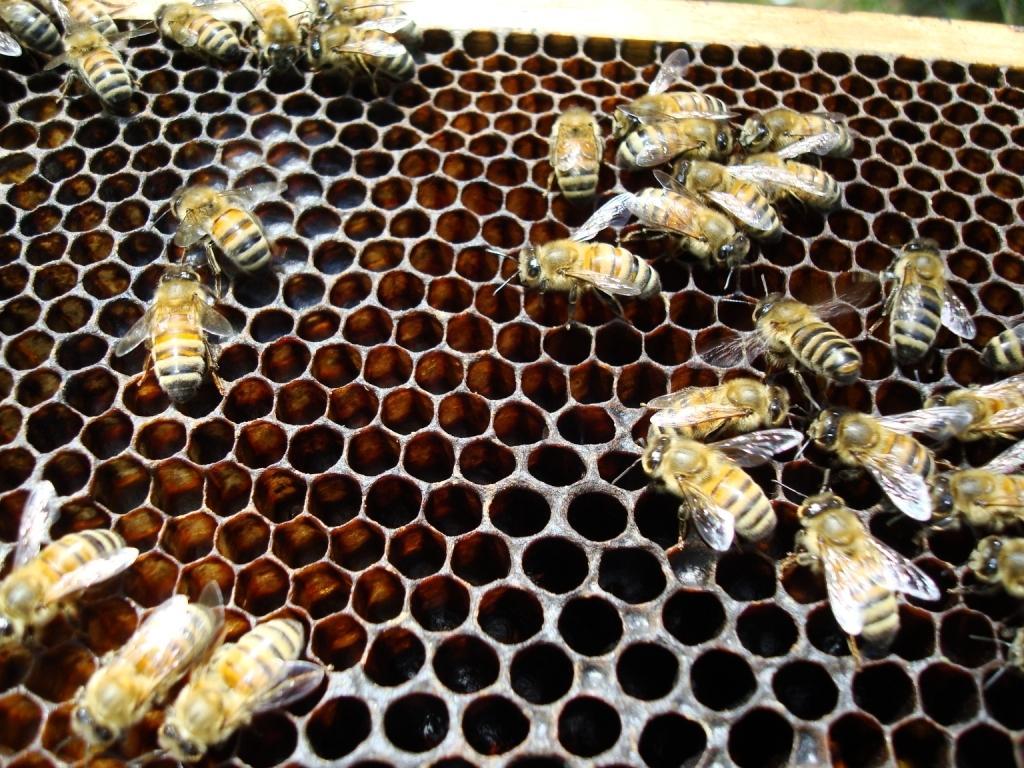Please provide a concise description of this image. As we can see in the image there are honey bees. 